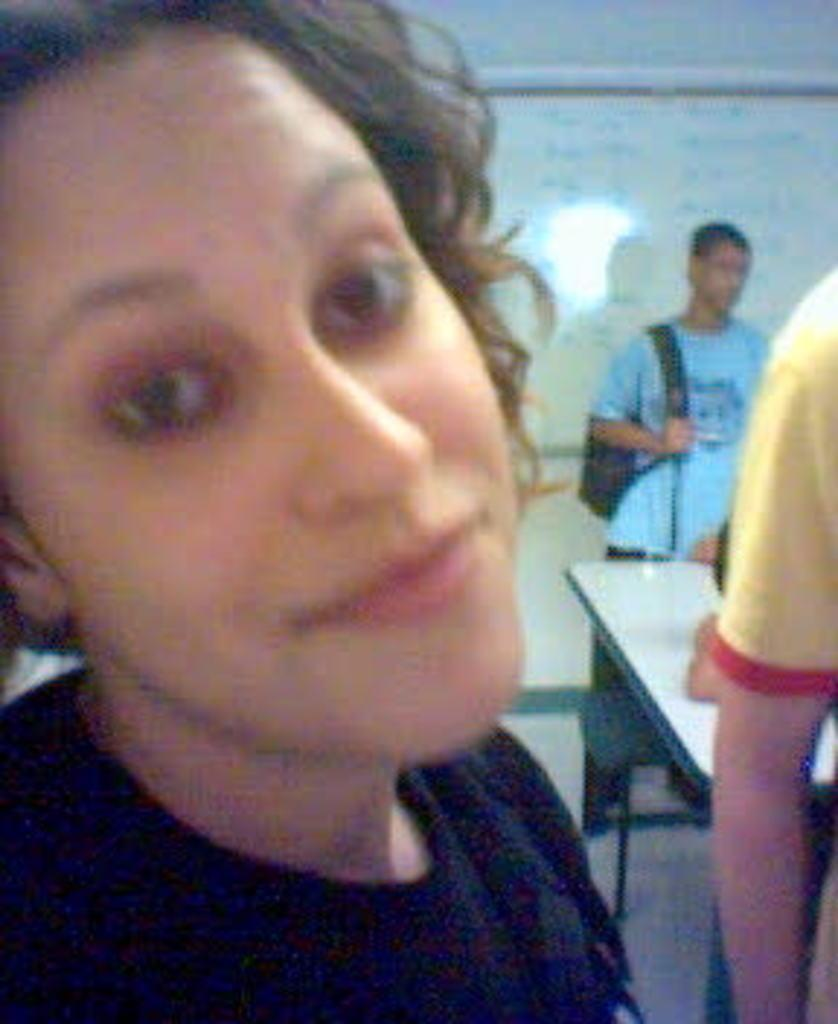How many people are in the image, and what are they wearing? There are people with different color dresses in the image. What is one person doing with their hands? One person is holding a bag. What can be seen to the right in the image? There is a table to the right in the image. What is on the wall in the background? There is a board on the wall in the background. What type of voice can be heard coming from the donkey in the image? There is no donkey present in the image, so it is not possible to determine what type of voice might be heard. 